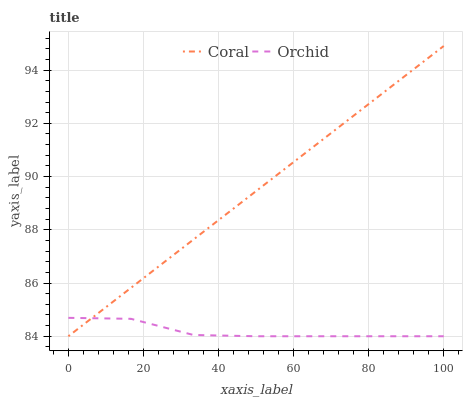Does Orchid have the minimum area under the curve?
Answer yes or no. Yes. Does Coral have the maximum area under the curve?
Answer yes or no. Yes. Does Orchid have the maximum area under the curve?
Answer yes or no. No. Is Coral the smoothest?
Answer yes or no. Yes. Is Orchid the roughest?
Answer yes or no. Yes. Is Orchid the smoothest?
Answer yes or no. No. Does Coral have the highest value?
Answer yes or no. Yes. Does Orchid have the highest value?
Answer yes or no. No. Does Coral intersect Orchid?
Answer yes or no. Yes. Is Coral less than Orchid?
Answer yes or no. No. Is Coral greater than Orchid?
Answer yes or no. No. 